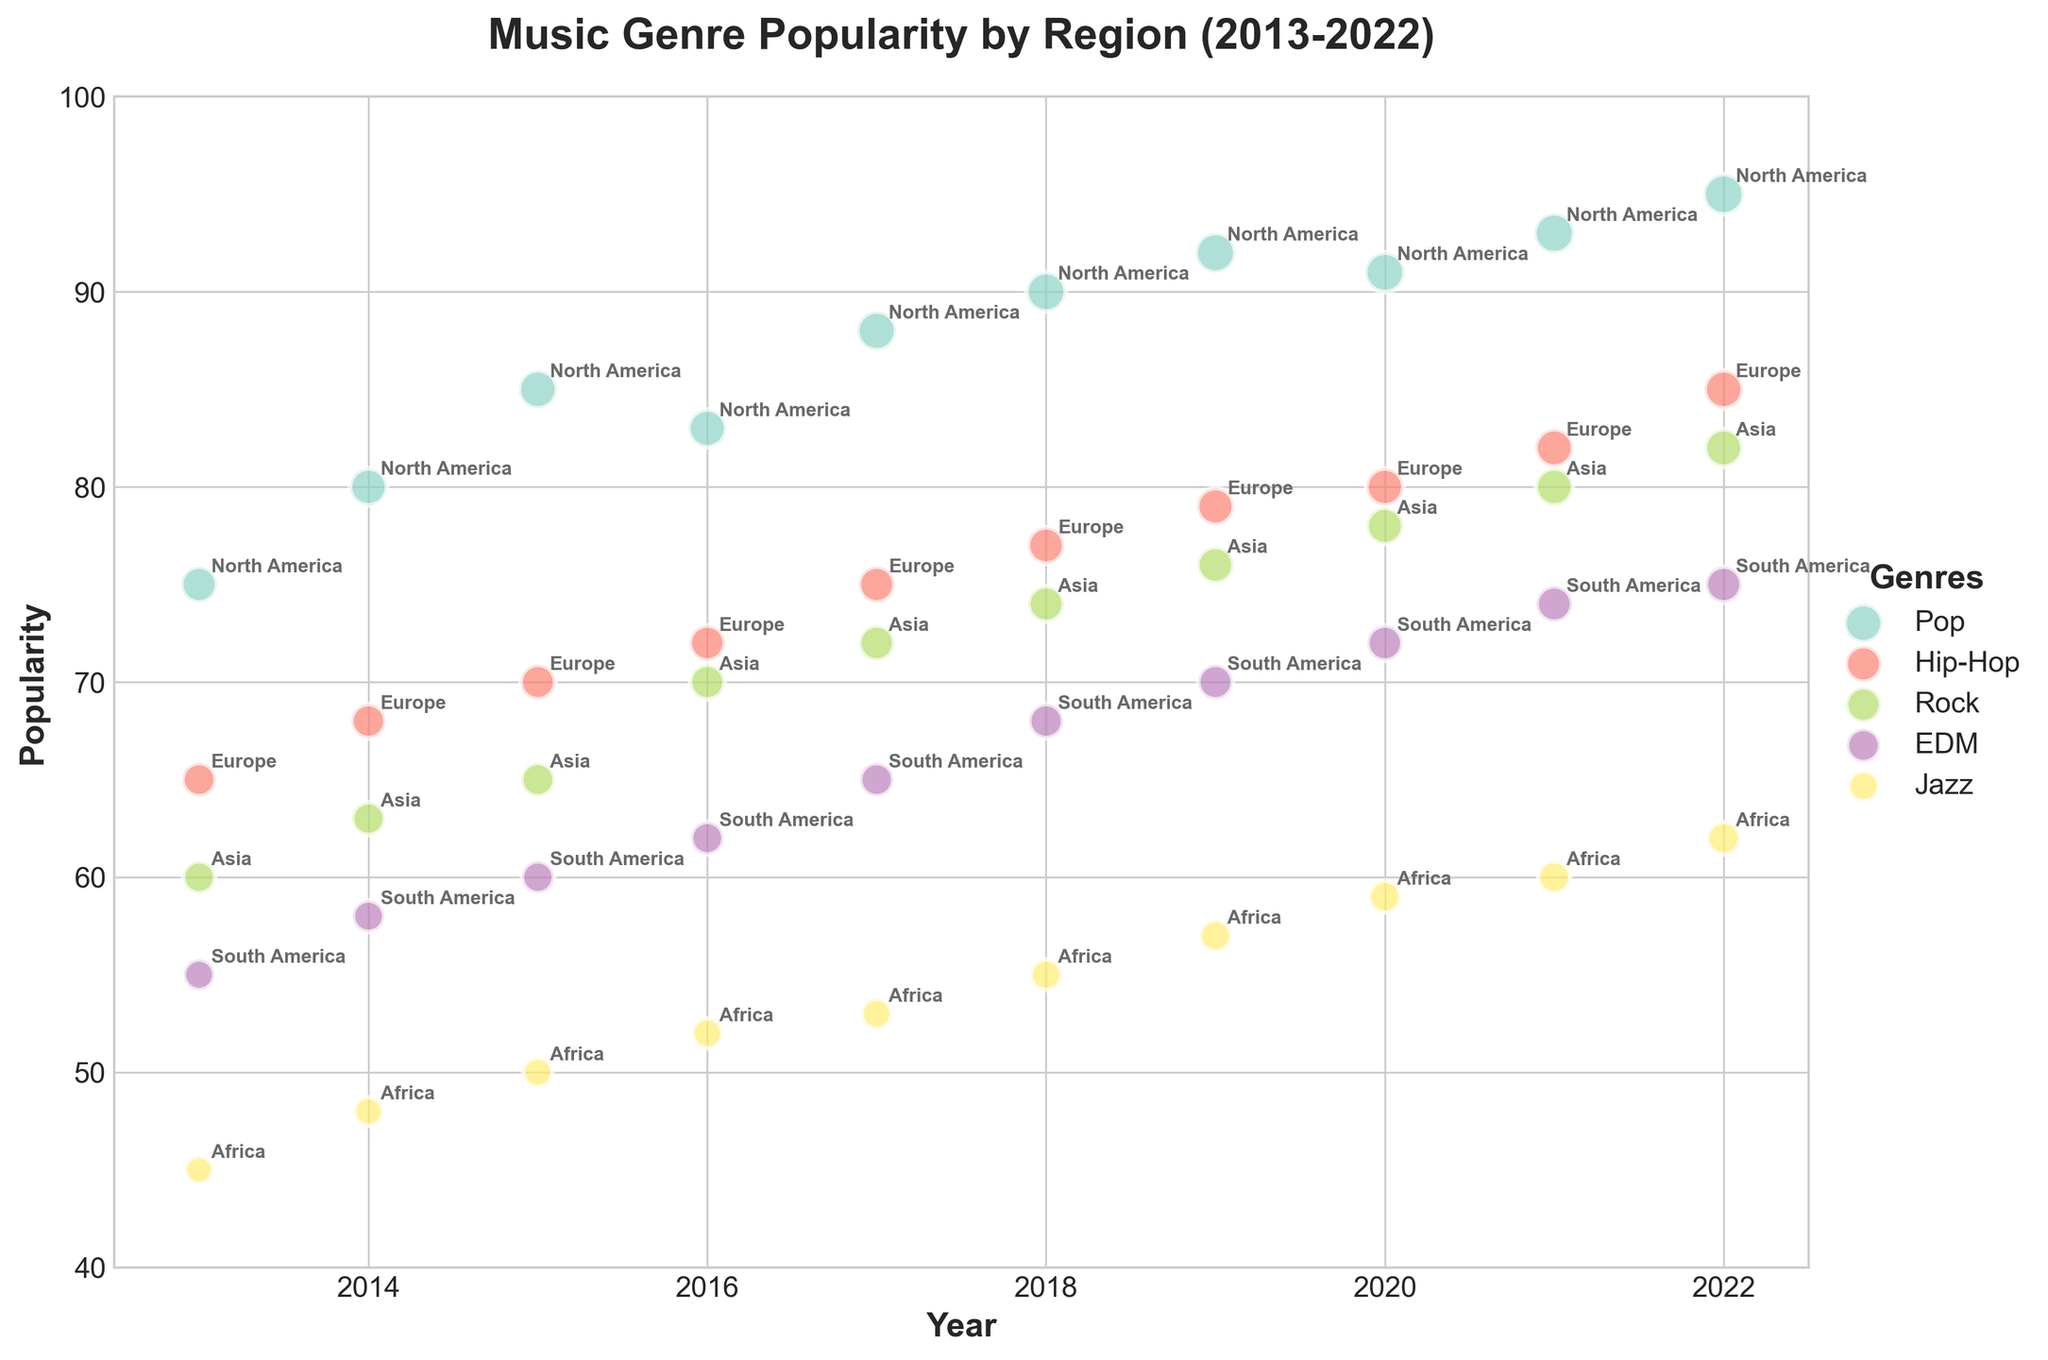Which genre shows the highest popularity in 2022? Look at the data points for all genres in the year 2022 and identify the highest Y-value. "Pop" in North America has a popularity of 95 in 2022, the highest among all.
Answer: Pop Which region has the lowest popularity for its respective genre in 2013? See the year 2013 and identify which region-genre pair has the lowest popularity. Jazz in Africa has the lowest popularity, which is 45.
Answer: Africa What is the difference in popularity between Pop in North America and Hip-Hop in Europe in 2020? In 2020, the popularity of Pop in North America is 91, and Hip-Hop in Europe is 80. Calculate the difference: 91 - 80.
Answer: 11 Which genre's popularity in Asia has shown continuous growth over the decade? Examine the trendlines for each genre in Asia over the years. Rock in Asia starts at 60 in 2013 and grows steadily to 82 by 2022, indicating continuous growth.
Answer: Rock Which genre in South America has seen the highest increase in popularity from 2013 to 2022? Subtract the 2013 popularity from the 2022 popularity for each genre in South America. EDM shows an increase from 55 to 75, the highest rise of 20 points.
Answer: EDM For the year 2015, which genre has more popularity in its respective region: Jazz in Africa or EDM in South America? Compare the popularity figures for Jazz in Africa (50) and EDM in South America (60) in 2015. EDM has more popularity at 60.
Answer: EDM Across all genres, which year exhibits the lowest overall popularity? Identify the year with the lowest Y-values across all genres. 2013 shows the lowest values in general, with Jazz in Africa at 45 being the lowest.
Answer: 2013 Between Pop in North America and Rock in Asia, which one has a higher growth rate from 2013 to 2022? For Pop, calculate (95-75)/75*100 = 26.67%. For Rock, calculate (82-60)/60*100 = 36.67%. Rock in Asia has a higher growth rate.
Answer: Rock Does any genre in any region experience a decline in popularity during the decade? Examine the trendlines for each genre-region pair; none of them show a decline as they all generally increase over the years.
Answer: No What is the average popularity of Jazz in Africa over the decade? Sum up the popularity figures from 2013 to 2022 for Jazz in Africa (45 + 48 + 50 + 52 + 53 + 55 + 57 + 59 + 60 + 62) and then divide by 10. The sum is 541 and the average is 54.1.
Answer: 54.1 